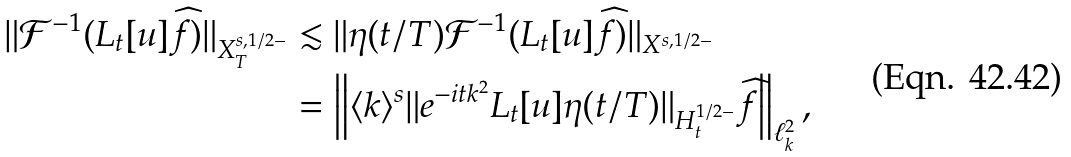Convert formula to latex. <formula><loc_0><loc_0><loc_500><loc_500>\| \mathcal { F } ^ { - 1 } ( L _ { t } [ u ] \widehat { f } ) \| _ { X ^ { s , 1 / 2 - } _ { T } } & \lesssim \| \eta ( t / T ) \mathcal { F } ^ { - 1 } ( L _ { t } [ u ] \widehat { f } ) \| _ { X ^ { s , 1 / 2 - } } \\ & = \left \| \langle k \rangle ^ { s } \| e ^ { - i t k ^ { 2 } } L _ { t } [ u ] \eta ( t / T ) \| _ { H ^ { 1 / 2 - } _ { t } } \widehat { f } \right \| _ { \ell ^ { 2 } _ { k } } ,</formula> 